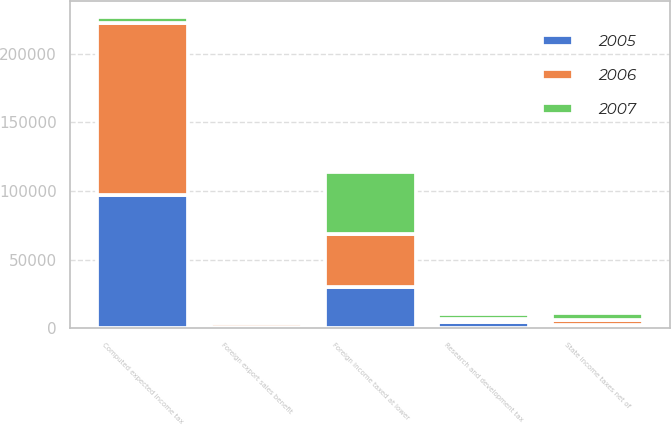Convert chart to OTSL. <chart><loc_0><loc_0><loc_500><loc_500><stacked_bar_chart><ecel><fcel>Computed expected income tax<fcel>State income taxes net of<fcel>Foreign export sales benefit<fcel>Research and development tax<fcel>Foreign income taxed at lower<nl><fcel>2007<fcel>4161.5<fcel>5103<fcel>658<fcel>3573<fcel>44993<nl><fcel>2006<fcel>125715<fcel>3548<fcel>2600<fcel>2095<fcel>38362<nl><fcel>2005<fcel>97044<fcel>2738<fcel>1111<fcel>4750<fcel>30438<nl></chart> 